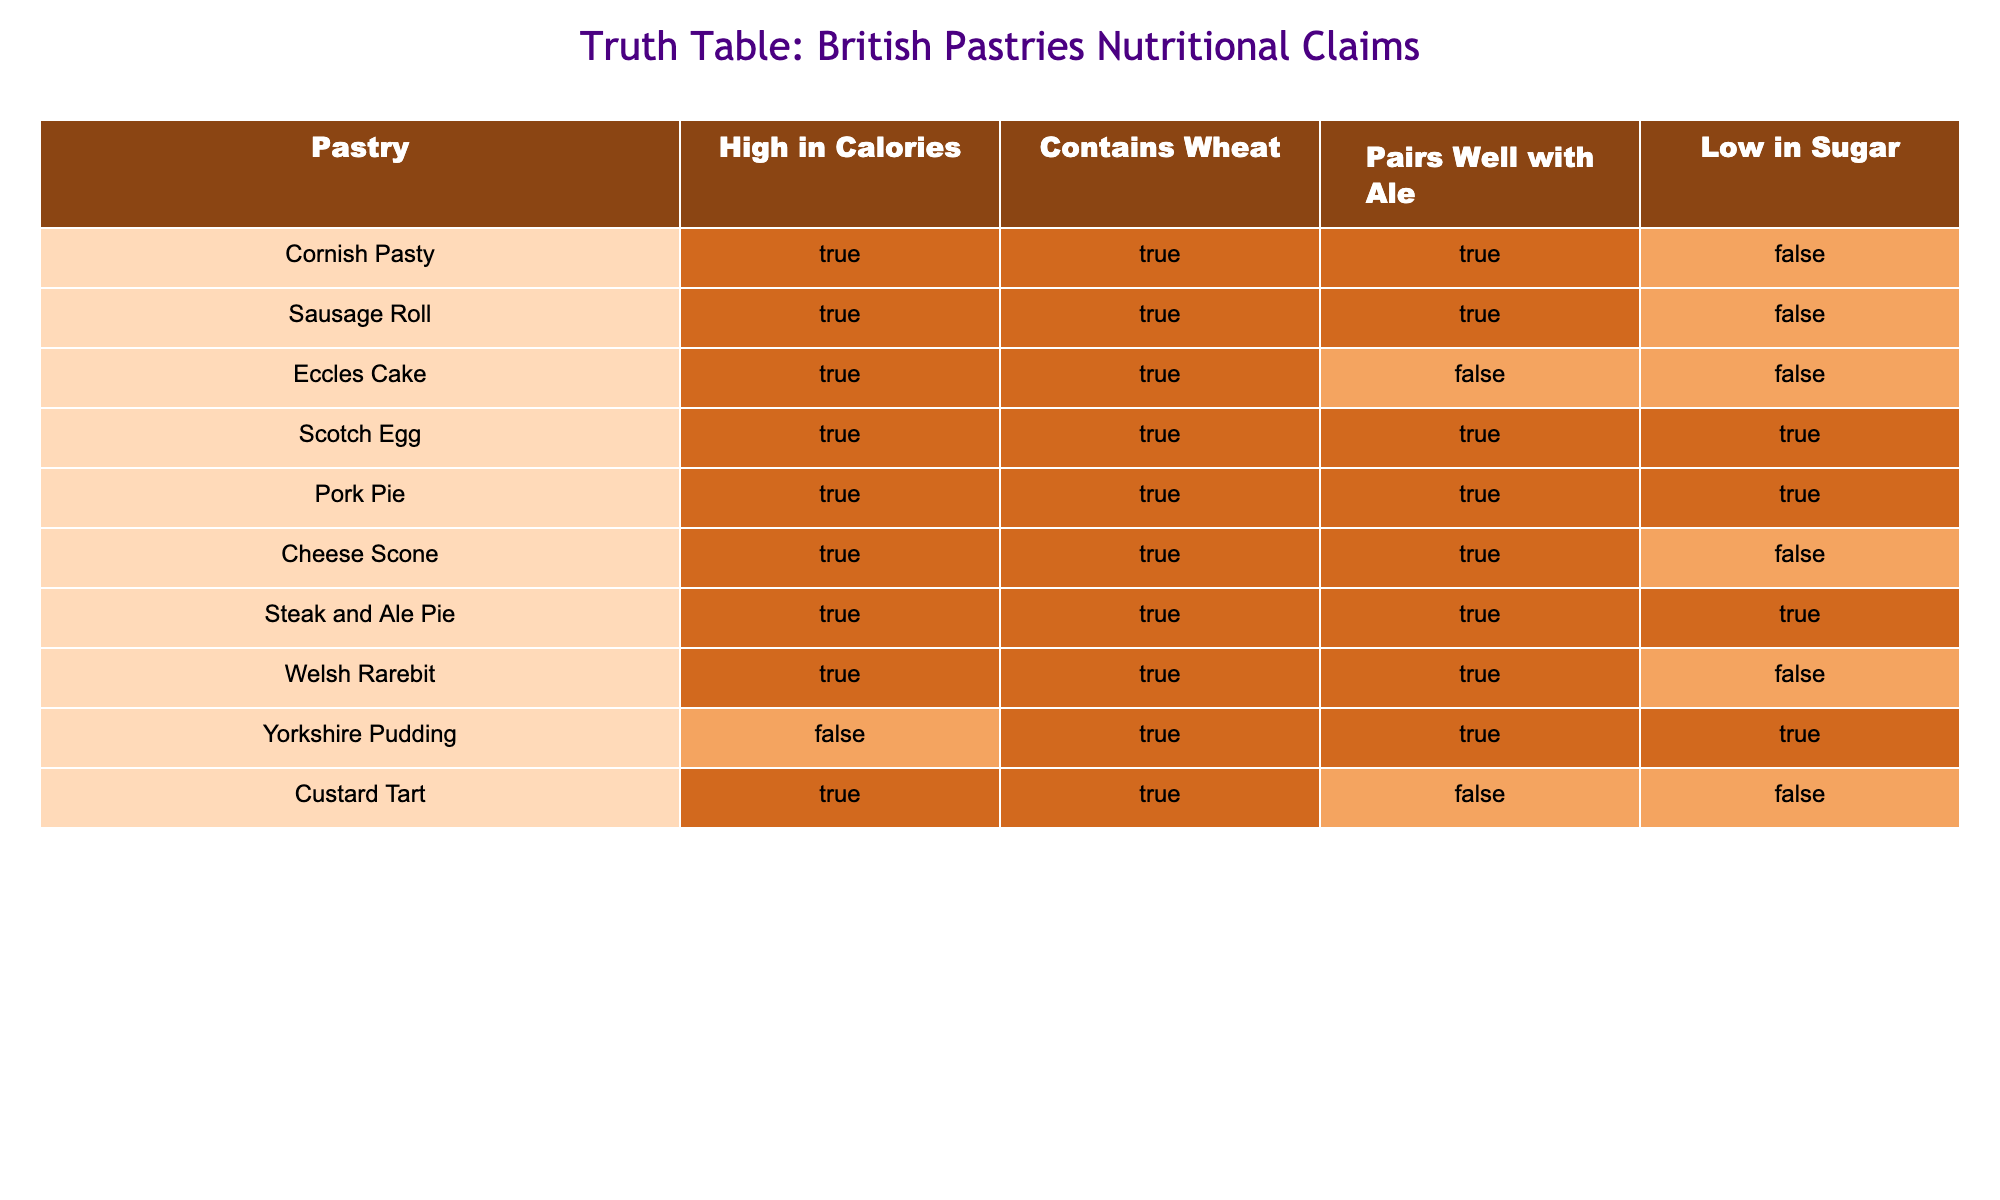What pastries are high in calories and pair well with ale? From the table, we can filter the pastries that are both marked TRUE for high in calories and pairs well with ale. The Cornish Pasty, Sausage Roll, Scotch Egg, Pork Pie, Cheese Scone, Steak and Ale Pie, and Welsh Rarebit meet this criterion.
Answer: Cornish Pasty, Sausage Roll, Scotch Egg, Pork Pie, Cheese Scone, Steak and Ale Pie, Welsh Rarebit Is the Yorkshire Pudding low in sugar? By looking at the table, we can see that the Yorkshire Pudding has a FALSE value in the 'Low in Sugar' column. Therefore, it is not low in sugar.
Answer: No How many pastries are high in calories? We can count the number of pastries in the table where the 'High in Calories' column is marked TRUE. The pastries are Cornish Pasty, Sausage Roll, Eccles Cake, Scotch Egg, Pork Pie, Cheese Scone, Steak and Ale Pie, Welsh Rarebit, Yorkshire Pudding, and Custard Tart, totaling 10.
Answer: 10 Which pastry pairs well with ale but is low in sugar? We need to find the pastries that are marked TRUE in the 'Pairs Well with Ale' column and FALSE in the 'Low in Sugar' column. The only pastry that fits this description is the Scotch Egg.
Answer: Scotch Egg Are there any pastries that are high in calories, contain wheat, and are low in sugar? We need to check for pastries that have TRUE in both the 'High in Calories' and 'Contains Wheat' columns, and FALSE in the 'Low in Sugar' column. The only one that meets these criteria is the Cornish Pasty, Sausage Roll, Eccles Cake, Cheese Scone, and Custard Tart. So, there are no pastries that fulfill all three claims.
Answer: No How many pastries contain wheat and are also high in calories? We can count the pastries that are marked TRUE in both the 'Contains Wheat' and 'High in Calories' columns. Based on the data, all pastries except for Yorkshire Pudding and Cornish Pasty are marked TRUE, giving us a total of 8 pastries.
Answer: 8 Is the Custard Tart a good low-sugar pastry that pairs well with ale? We check the 'Low in Sugar' column, where Custard Tart is FALSE, and the 'Pairs Well with Ale' column, where it is also FALSE. Hence, the Custard Tart does not satisfy either condition for low sugar or pairing well with ale.
Answer: No Which pastry has the highest nutritional content based on calorie count? The question is not answerable based on the data provided as all listed pastries are termed high in calories. Therefore, no single pastry stands out as having the highest nutritional content regarding calories.
Answer: Not applicable 